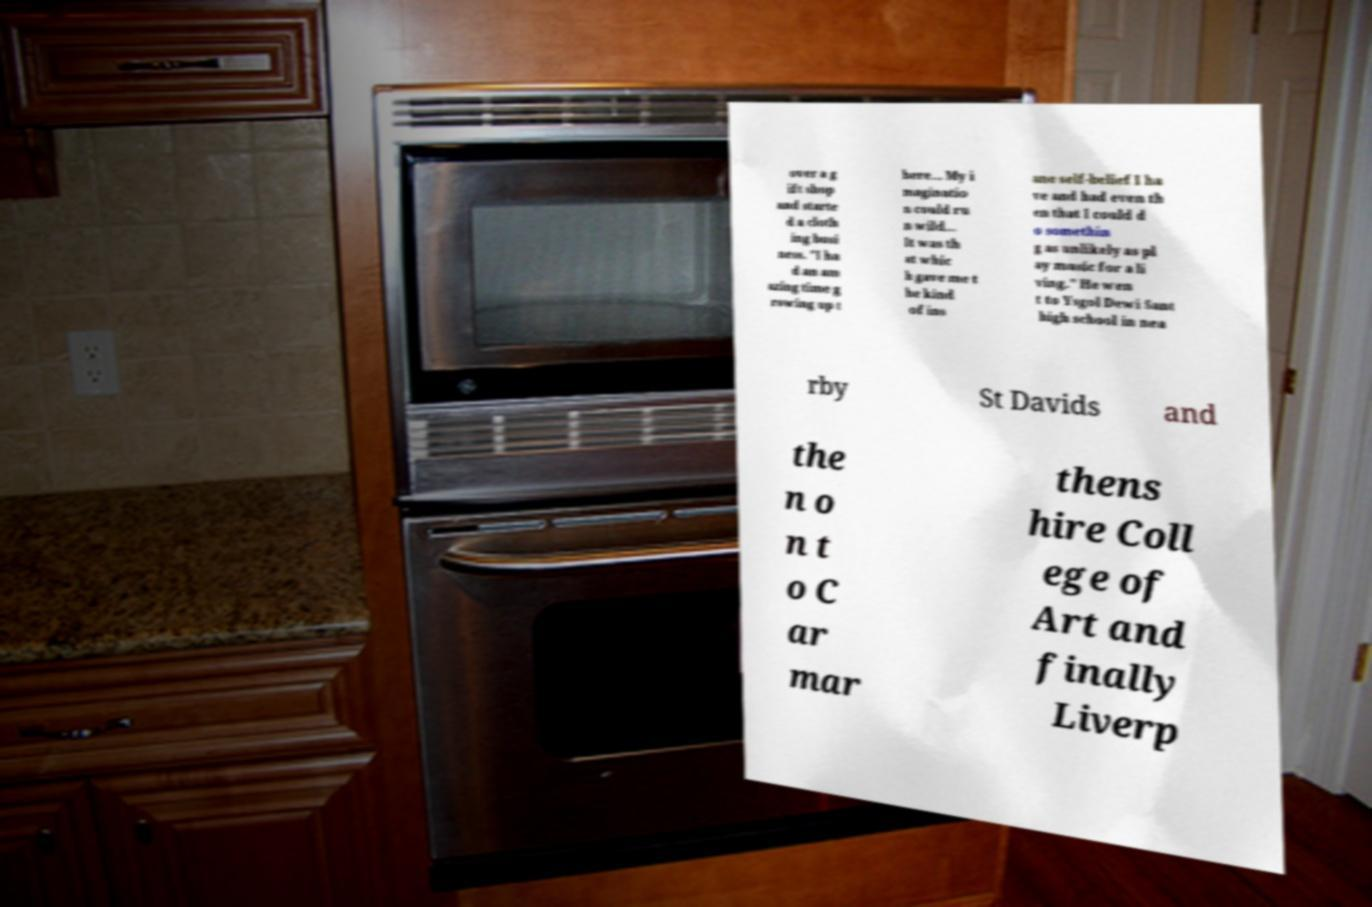Can you accurately transcribe the text from the provided image for me? over a g ift shop and starte d a cloth ing busi ness. "I ha d an am azing time g rowing up t here... My i maginatio n could ru n wild... It was th at whic h gave me t he kind of ins ane self-belief I ha ve and had even th en that I could d o somethin g as unlikely as pl ay music for a li ving." He wen t to Ysgol Dewi Sant high school in nea rby St Davids and the n o n t o C ar mar thens hire Coll ege of Art and finally Liverp 